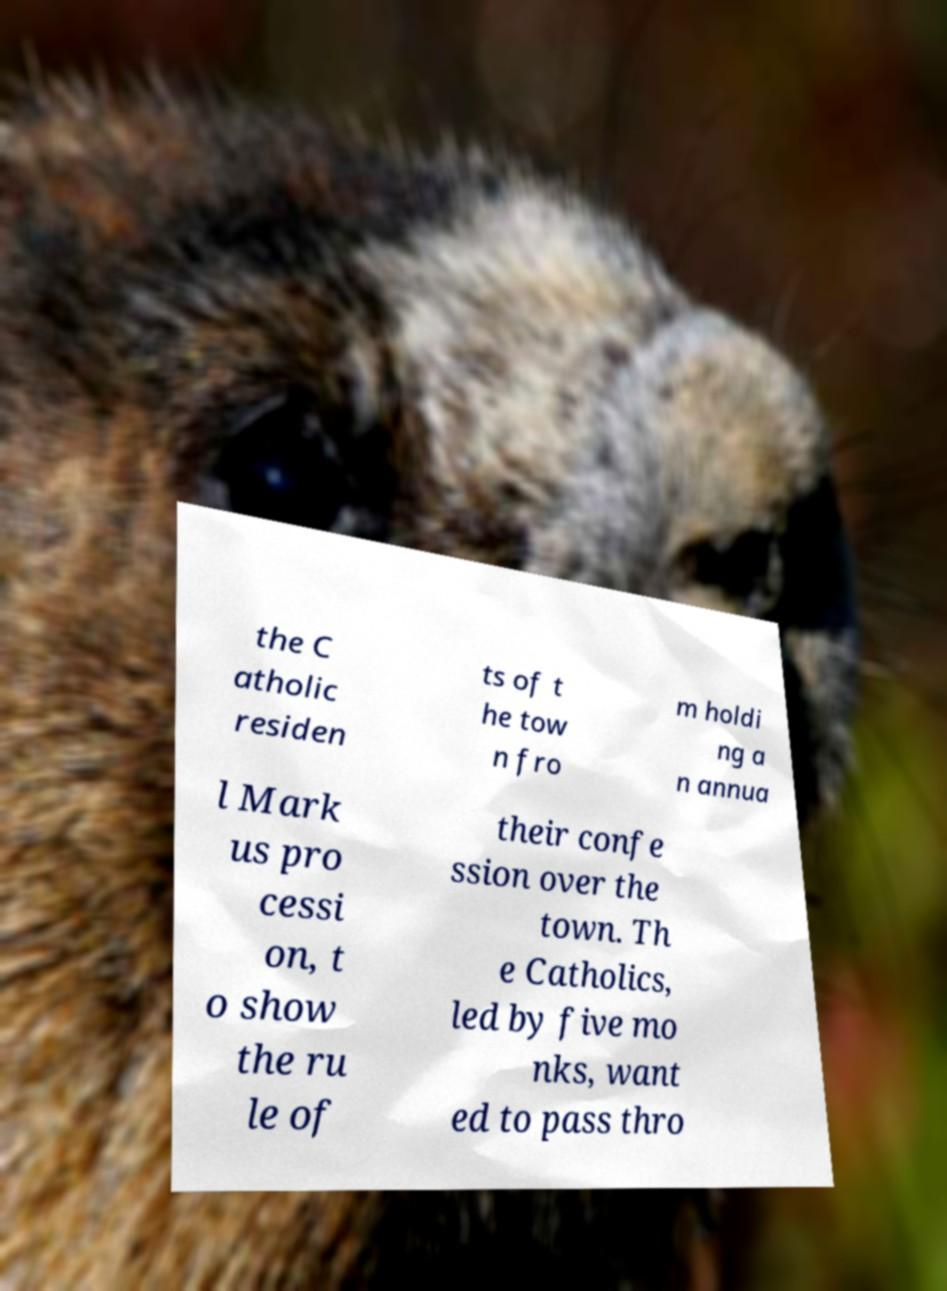Please identify and transcribe the text found in this image. the C atholic residen ts of t he tow n fro m holdi ng a n annua l Mark us pro cessi on, t o show the ru le of their confe ssion over the town. Th e Catholics, led by five mo nks, want ed to pass thro 